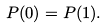Convert formula to latex. <formula><loc_0><loc_0><loc_500><loc_500>P ( 0 ) = P ( 1 ) .</formula> 